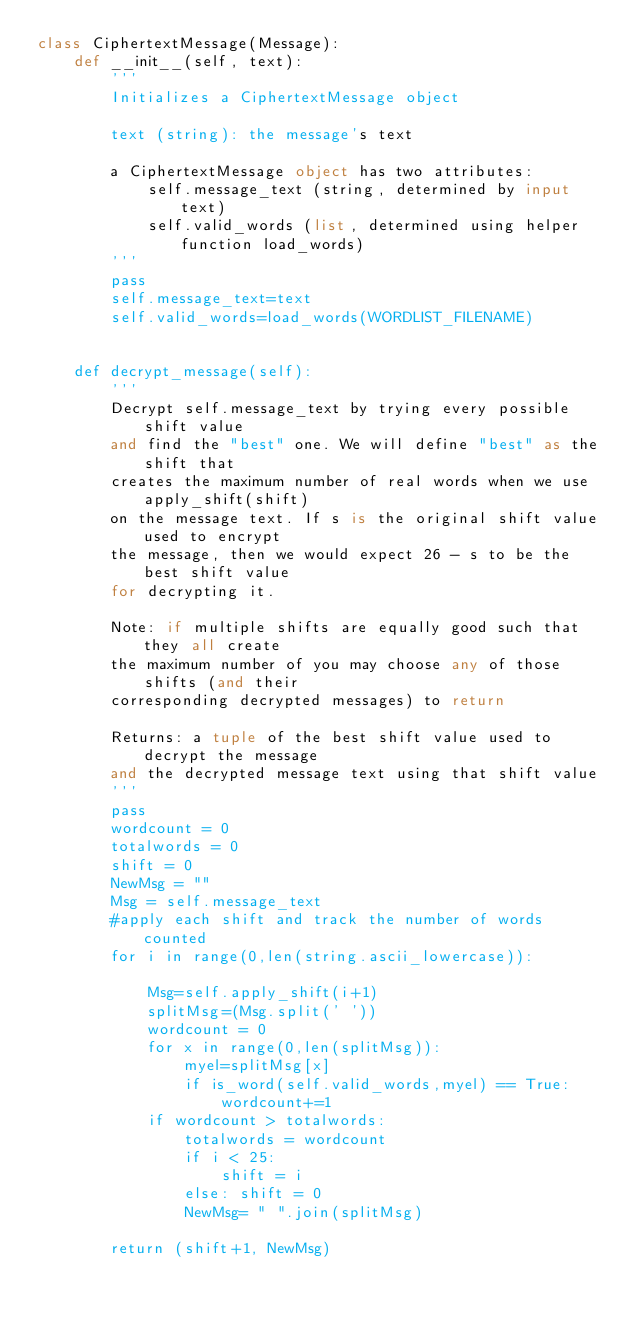<code> <loc_0><loc_0><loc_500><loc_500><_Python_>class CiphertextMessage(Message):
    def __init__(self, text):
        '''
        Initializes a CiphertextMessage object
                
        text (string): the message's text

        a CiphertextMessage object has two attributes:
            self.message_text (string, determined by input text)
            self.valid_words (list, determined using helper function load_words)
        '''
        pass 
        self.message_text=text
        self.valid_words=load_words(WORDLIST_FILENAME)
    
 
    def decrypt_message(self):
        '''
        Decrypt self.message_text by trying every possible shift value
        and find the "best" one. We will define "best" as the shift that
        creates the maximum number of real words when we use apply_shift(shift)
        on the message text. If s is the original shift value used to encrypt
        the message, then we would expect 26 - s to be the best shift value 
        for decrypting it.

        Note: if multiple shifts are equally good such that they all create 
        the maximum number of you may choose any of those shifts (and their
        corresponding decrypted messages) to return

        Returns: a tuple of the best shift value used to decrypt the message
        and the decrypted message text using that shift value
        '''
        pass
        wordcount = 0
        totalwords = 0
        shift = 0
        NewMsg = ""
        Msg = self.message_text
        #apply each shift and track the number of words counted
        for i in range(0,len(string.ascii_lowercase)):
           
            Msg=self.apply_shift(i+1)
            splitMsg=(Msg.split(' '))         
            wordcount = 0
            for x in range(0,len(splitMsg)): 
                myel=splitMsg[x]
                if is_word(self.valid_words,myel) == True:
                    wordcount+=1
            if wordcount > totalwords:
                totalwords = wordcount
                if i < 25:
                    shift = i   
                else: shift = 0
                NewMsg= " ".join(splitMsg)
                
        return (shift+1, NewMsg)  </code> 